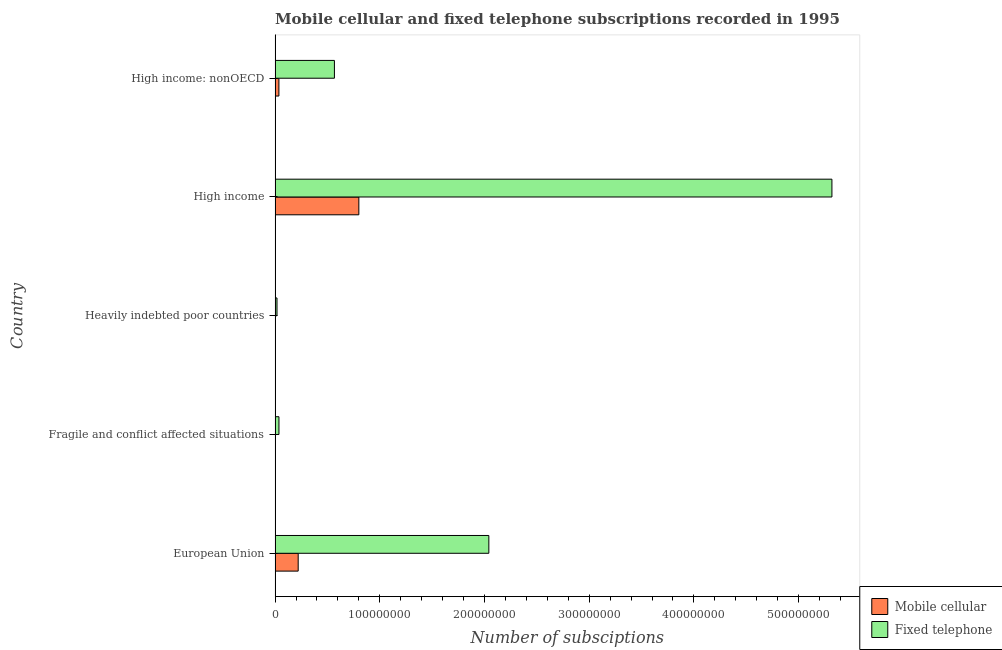How many different coloured bars are there?
Your response must be concise. 2. Are the number of bars on each tick of the Y-axis equal?
Your answer should be compact. Yes. How many bars are there on the 3rd tick from the top?
Offer a terse response. 2. How many bars are there on the 3rd tick from the bottom?
Offer a terse response. 2. What is the label of the 1st group of bars from the top?
Offer a terse response. High income: nonOECD. In how many cases, is the number of bars for a given country not equal to the number of legend labels?
Ensure brevity in your answer.  0. What is the number of fixed telephone subscriptions in High income: nonOECD?
Provide a succinct answer. 5.67e+07. Across all countries, what is the maximum number of fixed telephone subscriptions?
Offer a very short reply. 5.32e+08. Across all countries, what is the minimum number of fixed telephone subscriptions?
Provide a short and direct response. 1.83e+06. In which country was the number of fixed telephone subscriptions minimum?
Keep it short and to the point. Heavily indebted poor countries. What is the total number of fixed telephone subscriptions in the graph?
Give a very brief answer. 7.98e+08. What is the difference between the number of mobile cellular subscriptions in Heavily indebted poor countries and that in High income?
Provide a succinct answer. -8.00e+07. What is the difference between the number of fixed telephone subscriptions in Heavily indebted poor countries and the number of mobile cellular subscriptions in Fragile and conflict affected situations?
Your response must be concise. 1.69e+06. What is the average number of mobile cellular subscriptions per country?
Ensure brevity in your answer.  2.12e+07. What is the difference between the number of fixed telephone subscriptions and number of mobile cellular subscriptions in High income: nonOECD?
Your response must be concise. 5.30e+07. In how many countries, is the number of mobile cellular subscriptions greater than 140000000 ?
Your answer should be compact. 0. What is the ratio of the number of mobile cellular subscriptions in Fragile and conflict affected situations to that in High income: nonOECD?
Your response must be concise. 0.04. What is the difference between the highest and the second highest number of fixed telephone subscriptions?
Provide a short and direct response. 3.28e+08. What is the difference between the highest and the lowest number of mobile cellular subscriptions?
Make the answer very short. 8.00e+07. Is the sum of the number of mobile cellular subscriptions in Fragile and conflict affected situations and Heavily indebted poor countries greater than the maximum number of fixed telephone subscriptions across all countries?
Provide a succinct answer. No. What does the 2nd bar from the top in High income: nonOECD represents?
Provide a short and direct response. Mobile cellular. What does the 1st bar from the bottom in Fragile and conflict affected situations represents?
Provide a succinct answer. Mobile cellular. Are all the bars in the graph horizontal?
Provide a short and direct response. Yes. Does the graph contain any zero values?
Ensure brevity in your answer.  No. Does the graph contain grids?
Offer a very short reply. No. Where does the legend appear in the graph?
Your answer should be compact. Bottom right. How many legend labels are there?
Your answer should be very brief. 2. What is the title of the graph?
Make the answer very short. Mobile cellular and fixed telephone subscriptions recorded in 1995. What is the label or title of the X-axis?
Your response must be concise. Number of subsciptions. What is the Number of subsciptions in Mobile cellular in European Union?
Offer a very short reply. 2.21e+07. What is the Number of subsciptions of Fixed telephone in European Union?
Give a very brief answer. 2.04e+08. What is the Number of subsciptions of Mobile cellular in Fragile and conflict affected situations?
Keep it short and to the point. 1.43e+05. What is the Number of subsciptions of Fixed telephone in Fragile and conflict affected situations?
Give a very brief answer. 3.71e+06. What is the Number of subsciptions of Mobile cellular in Heavily indebted poor countries?
Provide a short and direct response. 4.30e+04. What is the Number of subsciptions of Fixed telephone in Heavily indebted poor countries?
Provide a short and direct response. 1.83e+06. What is the Number of subsciptions of Mobile cellular in High income?
Your response must be concise. 8.00e+07. What is the Number of subsciptions in Fixed telephone in High income?
Provide a short and direct response. 5.32e+08. What is the Number of subsciptions of Mobile cellular in High income: nonOECD?
Give a very brief answer. 3.65e+06. What is the Number of subsciptions of Fixed telephone in High income: nonOECD?
Provide a short and direct response. 5.67e+07. Across all countries, what is the maximum Number of subsciptions in Mobile cellular?
Offer a very short reply. 8.00e+07. Across all countries, what is the maximum Number of subsciptions in Fixed telephone?
Give a very brief answer. 5.32e+08. Across all countries, what is the minimum Number of subsciptions of Mobile cellular?
Provide a short and direct response. 4.30e+04. Across all countries, what is the minimum Number of subsciptions of Fixed telephone?
Offer a terse response. 1.83e+06. What is the total Number of subsciptions in Mobile cellular in the graph?
Make the answer very short. 1.06e+08. What is the total Number of subsciptions in Fixed telephone in the graph?
Provide a short and direct response. 7.98e+08. What is the difference between the Number of subsciptions in Mobile cellular in European Union and that in Fragile and conflict affected situations?
Offer a terse response. 2.19e+07. What is the difference between the Number of subsciptions in Fixed telephone in European Union and that in Fragile and conflict affected situations?
Your response must be concise. 2.00e+08. What is the difference between the Number of subsciptions in Mobile cellular in European Union and that in Heavily indebted poor countries?
Offer a terse response. 2.20e+07. What is the difference between the Number of subsciptions of Fixed telephone in European Union and that in Heavily indebted poor countries?
Your response must be concise. 2.02e+08. What is the difference between the Number of subsciptions of Mobile cellular in European Union and that in High income?
Keep it short and to the point. -5.79e+07. What is the difference between the Number of subsciptions in Fixed telephone in European Union and that in High income?
Provide a short and direct response. -3.28e+08. What is the difference between the Number of subsciptions of Mobile cellular in European Union and that in High income: nonOECD?
Provide a succinct answer. 1.84e+07. What is the difference between the Number of subsciptions in Fixed telephone in European Union and that in High income: nonOECD?
Offer a very short reply. 1.47e+08. What is the difference between the Number of subsciptions of Mobile cellular in Fragile and conflict affected situations and that in Heavily indebted poor countries?
Your answer should be compact. 1.00e+05. What is the difference between the Number of subsciptions in Fixed telephone in Fragile and conflict affected situations and that in Heavily indebted poor countries?
Give a very brief answer. 1.87e+06. What is the difference between the Number of subsciptions of Mobile cellular in Fragile and conflict affected situations and that in High income?
Offer a very short reply. -7.99e+07. What is the difference between the Number of subsciptions in Fixed telephone in Fragile and conflict affected situations and that in High income?
Provide a succinct answer. -5.28e+08. What is the difference between the Number of subsciptions in Mobile cellular in Fragile and conflict affected situations and that in High income: nonOECD?
Provide a succinct answer. -3.51e+06. What is the difference between the Number of subsciptions of Fixed telephone in Fragile and conflict affected situations and that in High income: nonOECD?
Your response must be concise. -5.30e+07. What is the difference between the Number of subsciptions of Mobile cellular in Heavily indebted poor countries and that in High income?
Give a very brief answer. -8.00e+07. What is the difference between the Number of subsciptions in Fixed telephone in Heavily indebted poor countries and that in High income?
Provide a succinct answer. -5.30e+08. What is the difference between the Number of subsciptions in Mobile cellular in Heavily indebted poor countries and that in High income: nonOECD?
Your answer should be compact. -3.61e+06. What is the difference between the Number of subsciptions in Fixed telephone in Heavily indebted poor countries and that in High income: nonOECD?
Ensure brevity in your answer.  -5.48e+07. What is the difference between the Number of subsciptions of Mobile cellular in High income and that in High income: nonOECD?
Make the answer very short. 7.64e+07. What is the difference between the Number of subsciptions in Fixed telephone in High income and that in High income: nonOECD?
Provide a short and direct response. 4.75e+08. What is the difference between the Number of subsciptions of Mobile cellular in European Union and the Number of subsciptions of Fixed telephone in Fragile and conflict affected situations?
Make the answer very short. 1.84e+07. What is the difference between the Number of subsciptions in Mobile cellular in European Union and the Number of subsciptions in Fixed telephone in Heavily indebted poor countries?
Offer a terse response. 2.02e+07. What is the difference between the Number of subsciptions in Mobile cellular in European Union and the Number of subsciptions in Fixed telephone in High income?
Keep it short and to the point. -5.10e+08. What is the difference between the Number of subsciptions in Mobile cellular in European Union and the Number of subsciptions in Fixed telephone in High income: nonOECD?
Give a very brief answer. -3.46e+07. What is the difference between the Number of subsciptions of Mobile cellular in Fragile and conflict affected situations and the Number of subsciptions of Fixed telephone in Heavily indebted poor countries?
Offer a very short reply. -1.69e+06. What is the difference between the Number of subsciptions of Mobile cellular in Fragile and conflict affected situations and the Number of subsciptions of Fixed telephone in High income?
Your response must be concise. -5.32e+08. What is the difference between the Number of subsciptions of Mobile cellular in Fragile and conflict affected situations and the Number of subsciptions of Fixed telephone in High income: nonOECD?
Your answer should be compact. -5.65e+07. What is the difference between the Number of subsciptions of Mobile cellular in Heavily indebted poor countries and the Number of subsciptions of Fixed telephone in High income?
Provide a succinct answer. -5.32e+08. What is the difference between the Number of subsciptions in Mobile cellular in Heavily indebted poor countries and the Number of subsciptions in Fixed telephone in High income: nonOECD?
Make the answer very short. -5.66e+07. What is the difference between the Number of subsciptions in Mobile cellular in High income and the Number of subsciptions in Fixed telephone in High income: nonOECD?
Your response must be concise. 2.33e+07. What is the average Number of subsciptions of Mobile cellular per country?
Your answer should be compact. 2.12e+07. What is the average Number of subsciptions in Fixed telephone per country?
Provide a short and direct response. 1.60e+08. What is the difference between the Number of subsciptions in Mobile cellular and Number of subsciptions in Fixed telephone in European Union?
Offer a very short reply. -1.82e+08. What is the difference between the Number of subsciptions in Mobile cellular and Number of subsciptions in Fixed telephone in Fragile and conflict affected situations?
Your answer should be very brief. -3.56e+06. What is the difference between the Number of subsciptions of Mobile cellular and Number of subsciptions of Fixed telephone in Heavily indebted poor countries?
Ensure brevity in your answer.  -1.79e+06. What is the difference between the Number of subsciptions of Mobile cellular and Number of subsciptions of Fixed telephone in High income?
Give a very brief answer. -4.52e+08. What is the difference between the Number of subsciptions in Mobile cellular and Number of subsciptions in Fixed telephone in High income: nonOECD?
Keep it short and to the point. -5.30e+07. What is the ratio of the Number of subsciptions in Mobile cellular in European Union to that in Fragile and conflict affected situations?
Your answer should be very brief. 153.91. What is the ratio of the Number of subsciptions in Fixed telephone in European Union to that in Fragile and conflict affected situations?
Your answer should be very brief. 55.09. What is the ratio of the Number of subsciptions of Mobile cellular in European Union to that in Heavily indebted poor countries?
Ensure brevity in your answer.  512.9. What is the ratio of the Number of subsciptions of Fixed telephone in European Union to that in Heavily indebted poor countries?
Ensure brevity in your answer.  111.42. What is the ratio of the Number of subsciptions of Mobile cellular in European Union to that in High income?
Make the answer very short. 0.28. What is the ratio of the Number of subsciptions in Fixed telephone in European Union to that in High income?
Your answer should be compact. 0.38. What is the ratio of the Number of subsciptions in Mobile cellular in European Union to that in High income: nonOECD?
Ensure brevity in your answer.  6.04. What is the ratio of the Number of subsciptions in Fixed telephone in European Union to that in High income: nonOECD?
Keep it short and to the point. 3.6. What is the ratio of the Number of subsciptions in Mobile cellular in Fragile and conflict affected situations to that in Heavily indebted poor countries?
Your answer should be very brief. 3.33. What is the ratio of the Number of subsciptions of Fixed telephone in Fragile and conflict affected situations to that in Heavily indebted poor countries?
Offer a very short reply. 2.02. What is the ratio of the Number of subsciptions of Mobile cellular in Fragile and conflict affected situations to that in High income?
Offer a terse response. 0. What is the ratio of the Number of subsciptions of Fixed telephone in Fragile and conflict affected situations to that in High income?
Your answer should be compact. 0.01. What is the ratio of the Number of subsciptions in Mobile cellular in Fragile and conflict affected situations to that in High income: nonOECD?
Make the answer very short. 0.04. What is the ratio of the Number of subsciptions of Fixed telephone in Fragile and conflict affected situations to that in High income: nonOECD?
Make the answer very short. 0.07. What is the ratio of the Number of subsciptions in Fixed telephone in Heavily indebted poor countries to that in High income?
Give a very brief answer. 0. What is the ratio of the Number of subsciptions in Mobile cellular in Heavily indebted poor countries to that in High income: nonOECD?
Provide a short and direct response. 0.01. What is the ratio of the Number of subsciptions in Fixed telephone in Heavily indebted poor countries to that in High income: nonOECD?
Ensure brevity in your answer.  0.03. What is the ratio of the Number of subsciptions of Mobile cellular in High income to that in High income: nonOECD?
Ensure brevity in your answer.  21.89. What is the ratio of the Number of subsciptions of Fixed telephone in High income to that in High income: nonOECD?
Make the answer very short. 9.38. What is the difference between the highest and the second highest Number of subsciptions of Mobile cellular?
Provide a succinct answer. 5.79e+07. What is the difference between the highest and the second highest Number of subsciptions of Fixed telephone?
Keep it short and to the point. 3.28e+08. What is the difference between the highest and the lowest Number of subsciptions of Mobile cellular?
Your response must be concise. 8.00e+07. What is the difference between the highest and the lowest Number of subsciptions of Fixed telephone?
Make the answer very short. 5.30e+08. 